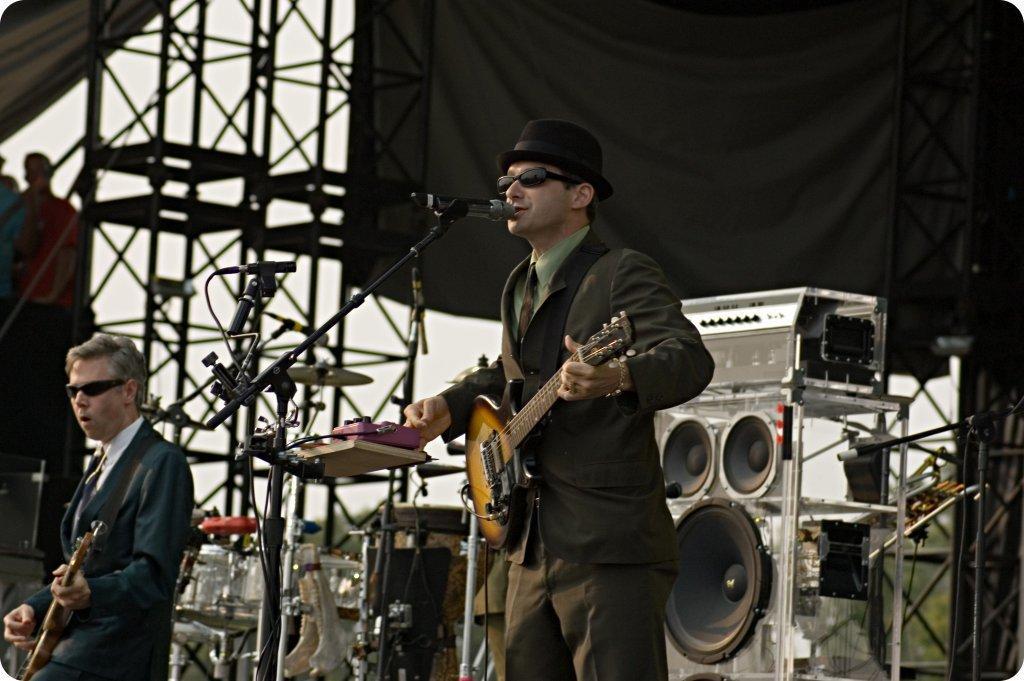Could you give a brief overview of what you see in this image? There is a man in suit wearing a spectacle, standing, holding and playing a guitar. In front of him, there is a mic and stand. Beside him, there is other person is playing guitar. In the background, there is a black sheet, a stage, speaker, trees, sky, some persons, and a roof. 